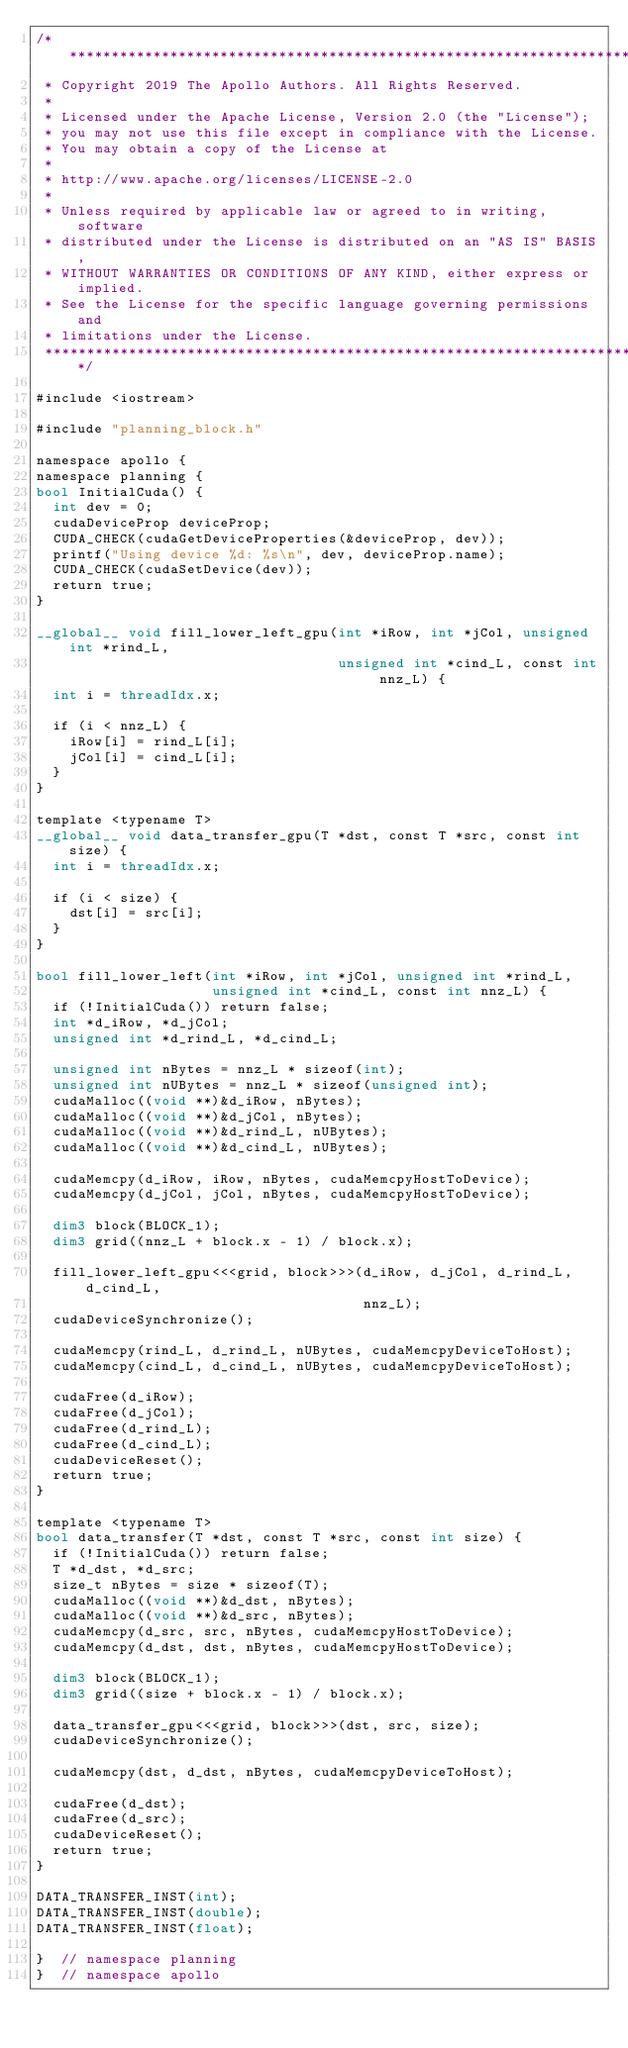Convert code to text. <code><loc_0><loc_0><loc_500><loc_500><_Cuda_>/******************************************************************************
 * Copyright 2019 The Apollo Authors. All Rights Reserved.
 *
 * Licensed under the Apache License, Version 2.0 (the "License");
 * you may not use this file except in compliance with the License.
 * You may obtain a copy of the License at
 *
 * http://www.apache.org/licenses/LICENSE-2.0
 *
 * Unless required by applicable law or agreed to in writing, software
 * distributed under the License is distributed on an "AS IS" BASIS,
 * WITHOUT WARRANTIES OR CONDITIONS OF ANY KIND, either express or implied.
 * See the License for the specific language governing permissions and
 * limitations under the License.
 *****************************************************************************/

#include <iostream>

#include "planning_block.h"

namespace apollo {
namespace planning {
bool InitialCuda() {
  int dev = 0;
  cudaDeviceProp deviceProp;
  CUDA_CHECK(cudaGetDeviceProperties(&deviceProp, dev));
  printf("Using device %d: %s\n", dev, deviceProp.name);
  CUDA_CHECK(cudaSetDevice(dev));
  return true;
}

__global__ void fill_lower_left_gpu(int *iRow, int *jCol, unsigned int *rind_L,
                                    unsigned int *cind_L, const int nnz_L) {
  int i = threadIdx.x;

  if (i < nnz_L) {
    iRow[i] = rind_L[i];
    jCol[i] = cind_L[i];
  }
}

template <typename T>
__global__ void data_transfer_gpu(T *dst, const T *src, const int size) {
  int i = threadIdx.x;

  if (i < size) {
    dst[i] = src[i];
  }
}

bool fill_lower_left(int *iRow, int *jCol, unsigned int *rind_L,
                     unsigned int *cind_L, const int nnz_L) {
  if (!InitialCuda()) return false;
  int *d_iRow, *d_jCol;
  unsigned int *d_rind_L, *d_cind_L;

  unsigned int nBytes = nnz_L * sizeof(int);
  unsigned int nUBytes = nnz_L * sizeof(unsigned int);
  cudaMalloc((void **)&d_iRow, nBytes);
  cudaMalloc((void **)&d_jCol, nBytes);
  cudaMalloc((void **)&d_rind_L, nUBytes);
  cudaMalloc((void **)&d_cind_L, nUBytes);

  cudaMemcpy(d_iRow, iRow, nBytes, cudaMemcpyHostToDevice);
  cudaMemcpy(d_jCol, jCol, nBytes, cudaMemcpyHostToDevice);

  dim3 block(BLOCK_1);
  dim3 grid((nnz_L + block.x - 1) / block.x);

  fill_lower_left_gpu<<<grid, block>>>(d_iRow, d_jCol, d_rind_L, d_cind_L,
                                       nnz_L);
  cudaDeviceSynchronize();

  cudaMemcpy(rind_L, d_rind_L, nUBytes, cudaMemcpyDeviceToHost);
  cudaMemcpy(cind_L, d_cind_L, nUBytes, cudaMemcpyDeviceToHost);

  cudaFree(d_iRow);
  cudaFree(d_jCol);
  cudaFree(d_rind_L);
  cudaFree(d_cind_L);
  cudaDeviceReset();
  return true;
}

template <typename T>
bool data_transfer(T *dst, const T *src, const int size) {
  if (!InitialCuda()) return false;
  T *d_dst, *d_src;
  size_t nBytes = size * sizeof(T);
  cudaMalloc((void **)&d_dst, nBytes);
  cudaMalloc((void **)&d_src, nBytes);
  cudaMemcpy(d_src, src, nBytes, cudaMemcpyHostToDevice);
  cudaMemcpy(d_dst, dst, nBytes, cudaMemcpyHostToDevice);

  dim3 block(BLOCK_1);
  dim3 grid((size + block.x - 1) / block.x);

  data_transfer_gpu<<<grid, block>>>(dst, src, size);
  cudaDeviceSynchronize();

  cudaMemcpy(dst, d_dst, nBytes, cudaMemcpyDeviceToHost);

  cudaFree(d_dst);
  cudaFree(d_src);
  cudaDeviceReset();
  return true;
}

DATA_TRANSFER_INST(int);
DATA_TRANSFER_INST(double);
DATA_TRANSFER_INST(float);

}  // namespace planning
}  // namespace apollo
</code> 